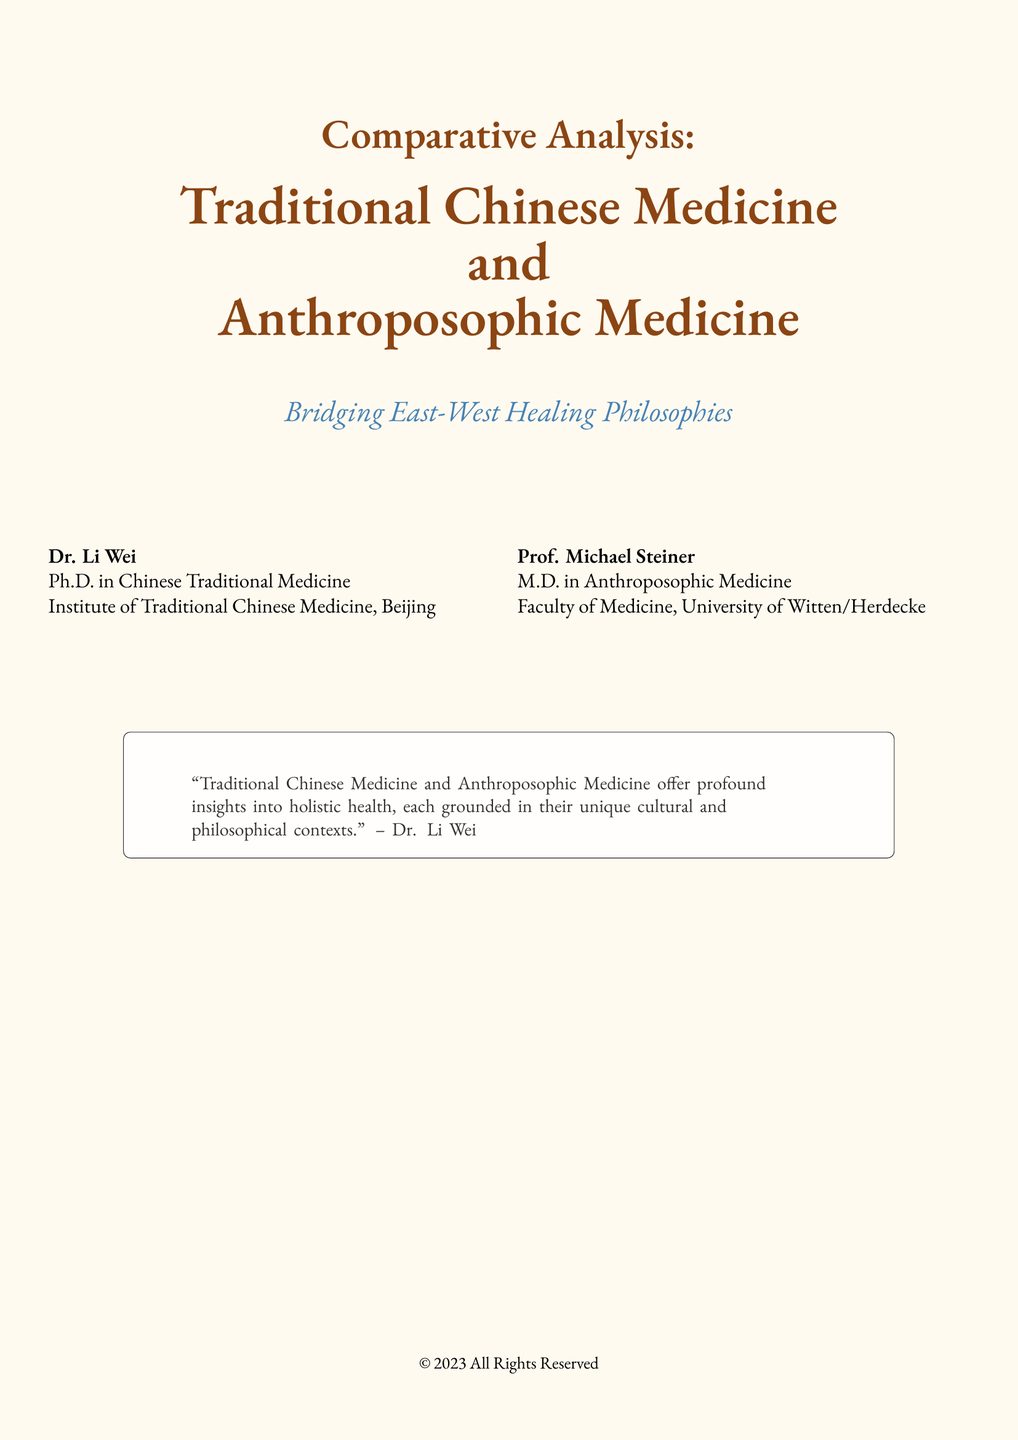What is the title of the book? The title of the book is highlighted prominently on the cover, which reads "Comparative Analysis: Traditional Chinese Medicine and Anthroposophic Medicine."
Answer: Comparative Analysis: Traditional Chinese Medicine and Anthroposophic Medicine Who is the author of the book? The author's name is listed at the bottom of the cover, and it includes both first and last names.
Answer: Dr. Li Wei What is the subtitle of the book? The subtitle provides additional context about the book's content, which is located beneath the main title.
Answer: Bridging East-West Healing Philosophies Who is the second author? The second author's name appears alongside the first author in separate columns on the cover.
Answer: Prof. Michael Steiner What degree does Dr. Li Wei hold? Dr. Li Wei's academic qualification is stated in the author's description section.
Answer: Ph.D. in Chinese Traditional Medicine In which city is the Institute of Traditional Chinese Medicine located? The location of the Institute is mentioned directly after the author's title.
Answer: Beijing What is the cultural significance mentioned by Dr. Li Wei? The quote from Dr. Li Wei reflects a broader theme found in the book, emphasizing the importance of cultural context in medicine.
Answer: Holistic health How many authors are listed on the cover? The number of authors can be determined by counting the names presented in the author section.
Answer: Two What type of medicine does Prof. Michael Steiner specialize in? Prof. Michael Steiner's area of expertise is stated in the author's description.
Answer: Anthroposophic Medicine 